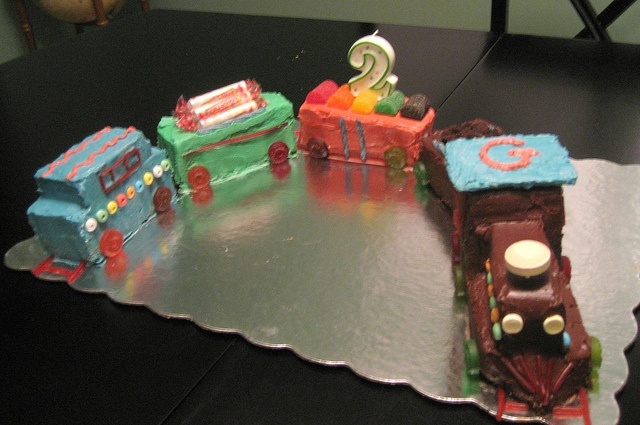Describe the objects in this image and their specific colors. I can see dining table in black, gray, darkgray, and maroon tones, cake in black, maroon, lightblue, and gray tones, cake in black, teal, gray, and darkgray tones, cake in black, salmon, brown, and red tones, and cake in black, green, lightgreen, darkgreen, and ivory tones in this image. 